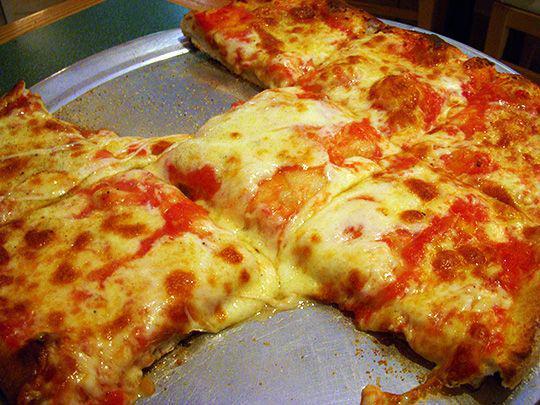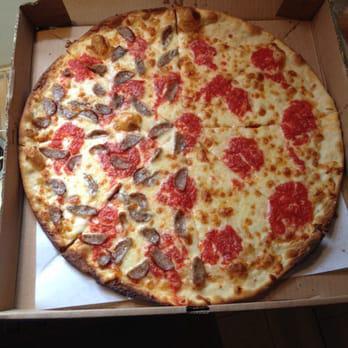The first image is the image on the left, the second image is the image on the right. For the images shown, is this caption "A pizza in one image is intact, while a second image shows a slice of pizza and a paper plate." true? Answer yes or no. No. The first image is the image on the left, the second image is the image on the right. Analyze the images presented: Is the assertion "The right image shows a whole pizza on a silver tray, and the left image shows one pizza slice on a white paper plate next to a silver tray containing less than a whole pizza." valid? Answer yes or no. No. 